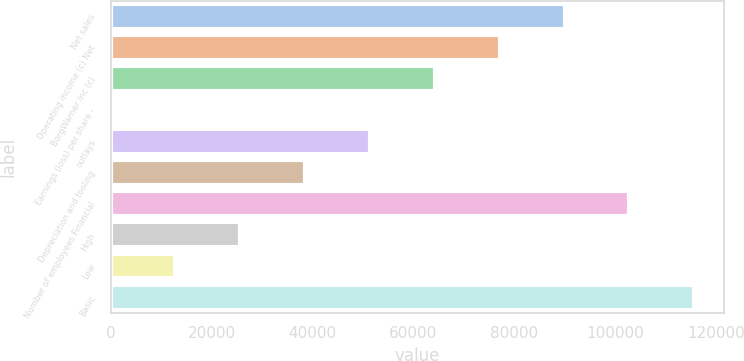Convert chart. <chart><loc_0><loc_0><loc_500><loc_500><bar_chart><fcel>Net sales<fcel>Operating income (c) Net<fcel>BorgWarner Inc (c)<fcel>Earnings (loss) per share -<fcel>outlays<fcel>Depreciation and tooling<fcel>Number of employees Financial<fcel>High<fcel>Low<fcel>Basic<nl><fcel>89929.1<fcel>77082.8<fcel>64236.5<fcel>5.04<fcel>51390.2<fcel>38543.9<fcel>102775<fcel>25697.6<fcel>12851.3<fcel>115622<nl></chart> 